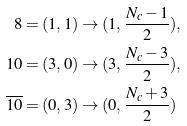Convert formula to latex. <formula><loc_0><loc_0><loc_500><loc_500>8 = ( 1 , 1 ) & \rightarrow ( 1 , \frac { N _ { c } - 1 } { 2 } ) , \\ 1 0 = ( 3 , 0 ) & \rightarrow ( 3 , \frac { N _ { c } - 3 } { 2 } ) , \\ \overline { 1 0 } = ( 0 , 3 ) & \rightarrow ( 0 , \frac { N _ { c } + 3 } { 2 } )</formula> 